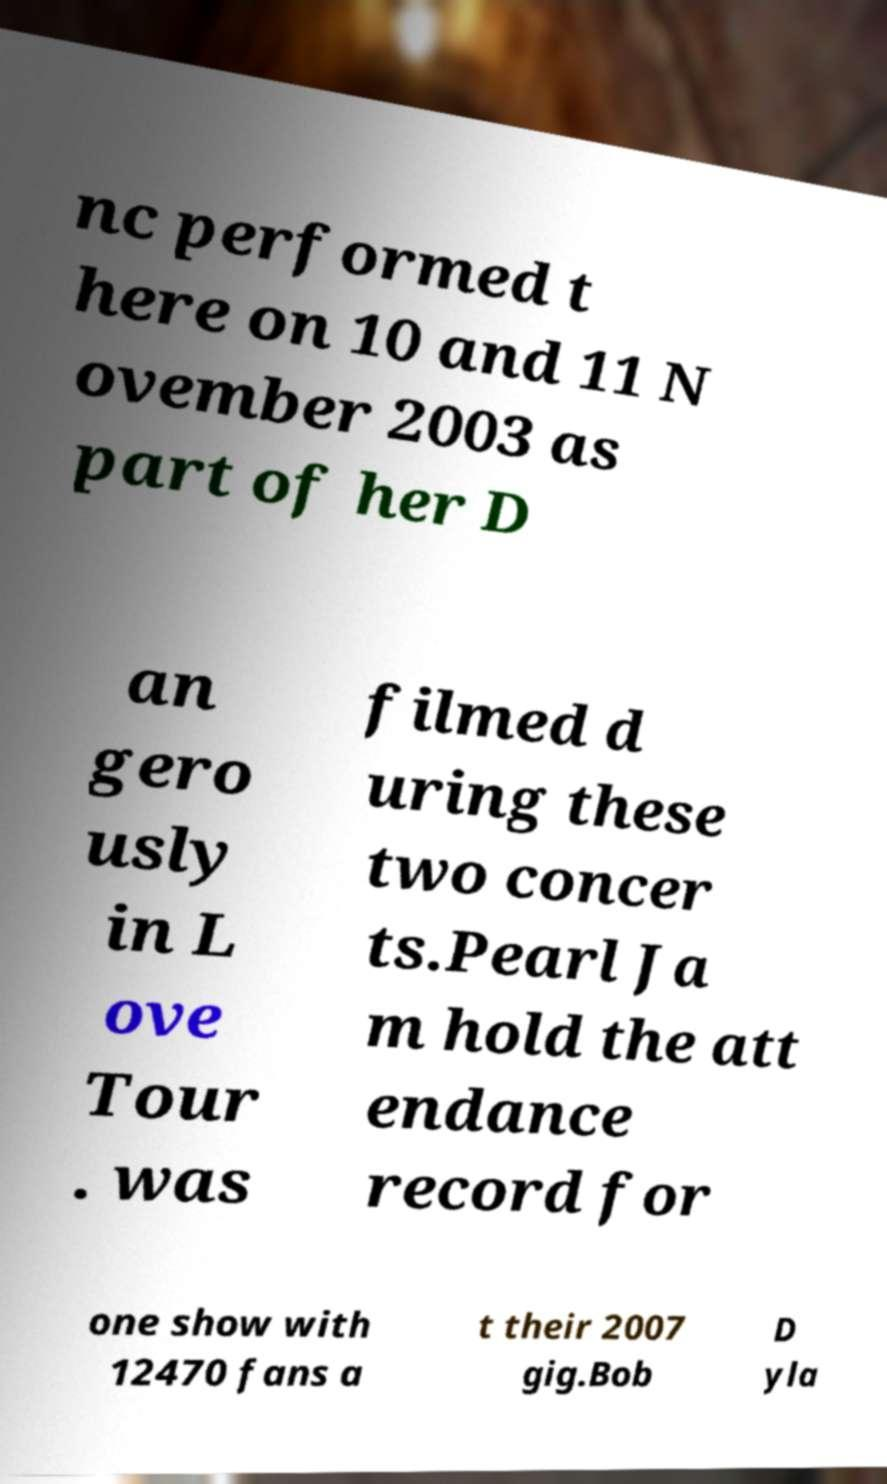For documentation purposes, I need the text within this image transcribed. Could you provide that? nc performed t here on 10 and 11 N ovember 2003 as part of her D an gero usly in L ove Tour . was filmed d uring these two concer ts.Pearl Ja m hold the att endance record for one show with 12470 fans a t their 2007 gig.Bob D yla 